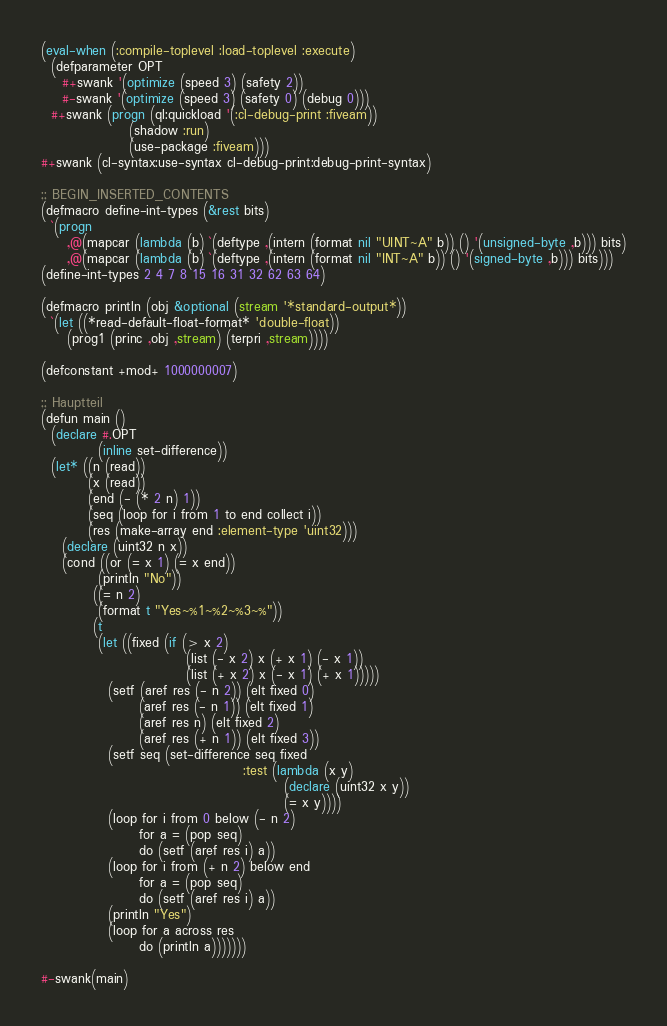<code> <loc_0><loc_0><loc_500><loc_500><_Lisp_>(eval-when (:compile-toplevel :load-toplevel :execute)
  (defparameter OPT
    #+swank '(optimize (speed 3) (safety 2))
    #-swank '(optimize (speed 3) (safety 0) (debug 0)))
  #+swank (progn (ql:quickload '(:cl-debug-print :fiveam))
                 (shadow :run)
                 (use-package :fiveam)))
#+swank (cl-syntax:use-syntax cl-debug-print:debug-print-syntax)

;; BEGIN_INSERTED_CONTENTS
(defmacro define-int-types (&rest bits)
  `(progn
     ,@(mapcar (lambda (b) `(deftype ,(intern (format nil "UINT~A" b)) () '(unsigned-byte ,b))) bits)
     ,@(mapcar (lambda (b) `(deftype ,(intern (format nil "INT~A" b)) () '(signed-byte ,b))) bits)))
(define-int-types 2 4 7 8 15 16 31 32 62 63 64)

(defmacro println (obj &optional (stream '*standard-output*))
  `(let ((*read-default-float-format* 'double-float))
     (prog1 (princ ,obj ,stream) (terpri ,stream))))

(defconstant +mod+ 1000000007)

;; Hauptteil
(defun main ()
  (declare #.OPT
           (inline set-difference))
  (let* ((n (read))
         (x (read))
         (end (- (* 2 n) 1))
         (seq (loop for i from 1 to end collect i))
         (res (make-array end :element-type 'uint32)))
    (declare (uint32 n x))
    (cond ((or (= x 1) (= x end))
           (println "No"))
          ((= n 2)
           (format t "Yes~%1~%2~%3~%"))
          (t
           (let ((fixed (if (> x 2)
                            (list (- x 2) x (+ x 1) (- x 1))
                            (list (+ x 2) x (- x 1) (+ x 1)))))
             (setf (aref res (- n 2)) (elt fixed 0)
                   (aref res (- n 1)) (elt fixed 1)
                   (aref res n) (elt fixed 2)
                   (aref res (+ n 1)) (elt fixed 3))
             (setf seq (set-difference seq fixed
                                       :test (lambda (x y)
                                               (declare (uint32 x y))
                                               (= x y))))
             (loop for i from 0 below (- n 2)
                   for a = (pop seq)
                   do (setf (aref res i) a))
             (loop for i from (+ n 2) below end
                   for a = (pop seq)
                   do (setf (aref res i) a))
             (println "Yes")
             (loop for a across res
                   do (println a)))))))

#-swank(main)

</code> 